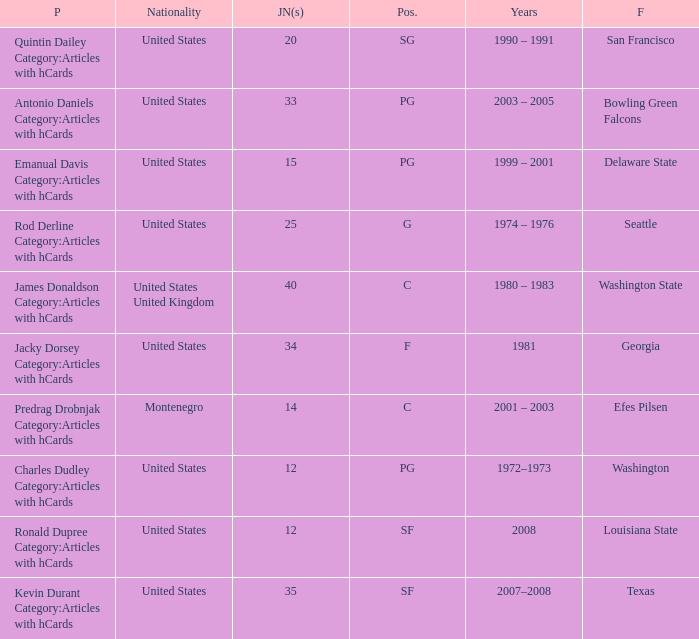What years did the united states player with a jersey number 25 who attended delaware state play? 1999 – 2001. Write the full table. {'header': ['P', 'Nationality', 'JN(s)', 'Pos.', 'Years', 'F'], 'rows': [['Quintin Dailey Category:Articles with hCards', 'United States', '20', 'SG', '1990 – 1991', 'San Francisco'], ['Antonio Daniels Category:Articles with hCards', 'United States', '33', 'PG', '2003 – 2005', 'Bowling Green Falcons'], ['Emanual Davis Category:Articles with hCards', 'United States', '15', 'PG', '1999 – 2001', 'Delaware State'], ['Rod Derline Category:Articles with hCards', 'United States', '25', 'G', '1974 – 1976', 'Seattle'], ['James Donaldson Category:Articles with hCards', 'United States United Kingdom', '40', 'C', '1980 – 1983', 'Washington State'], ['Jacky Dorsey Category:Articles with hCards', 'United States', '34', 'F', '1981', 'Georgia'], ['Predrag Drobnjak Category:Articles with hCards', 'Montenegro', '14', 'C', '2001 – 2003', 'Efes Pilsen'], ['Charles Dudley Category:Articles with hCards', 'United States', '12', 'PG', '1972–1973', 'Washington'], ['Ronald Dupree Category:Articles with hCards', 'United States', '12', 'SF', '2008', 'Louisiana State'], ['Kevin Durant Category:Articles with hCards', 'United States', '35', 'SF', '2007–2008', 'Texas']]} 